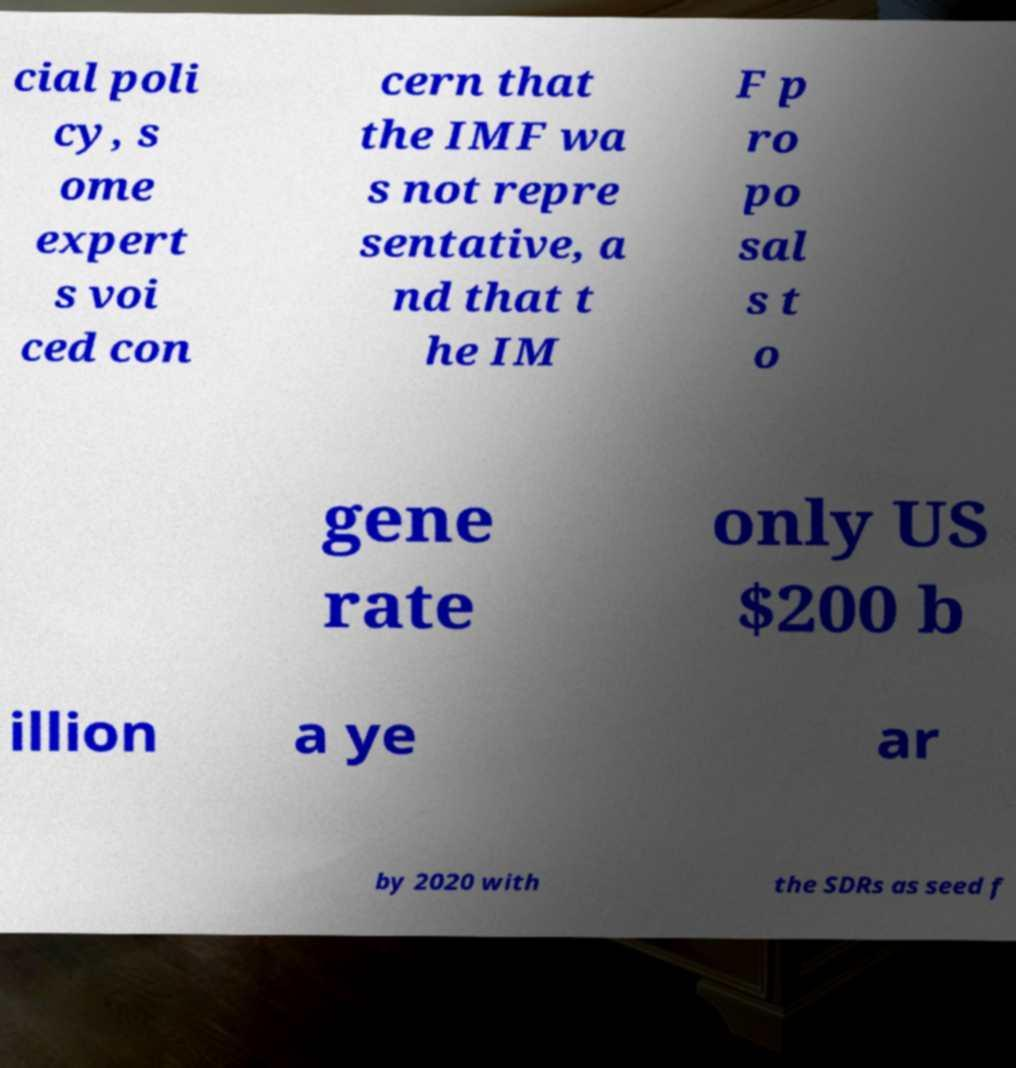Could you extract and type out the text from this image? cial poli cy, s ome expert s voi ced con cern that the IMF wa s not repre sentative, a nd that t he IM F p ro po sal s t o gene rate only US $200 b illion a ye ar by 2020 with the SDRs as seed f 